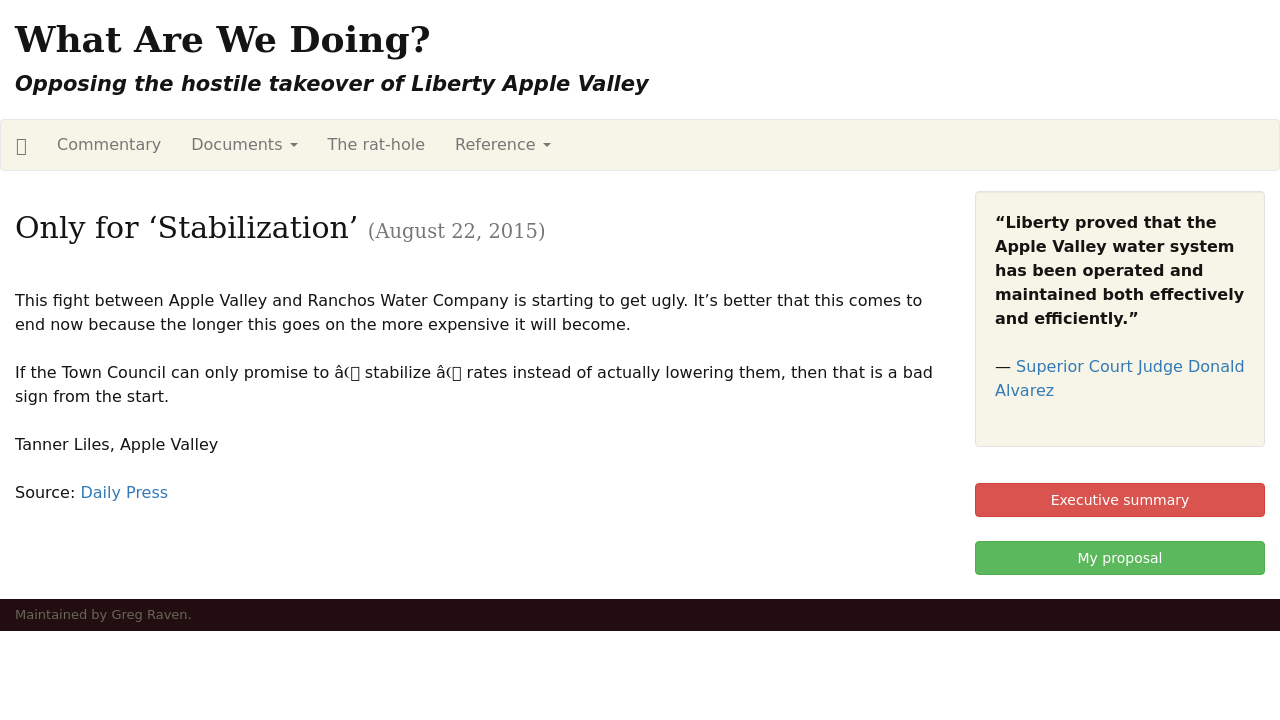Can you tell me more about the content displayed on the website about the takeover of Liberty Apple Valley? The website content is focused on opposing the hostile takeover of Liberty Apple Valley by a rival company. It includes various sections like commentary, documents, and reference links, providing resources and opinions on the matter. The main article titled 'Only for Stabilization' discusses the financial implications of the takeover and criticizes the town council's promise to only stabilize rates rather than reducing them, suggesting skepticism about the benefits of the takeover. 